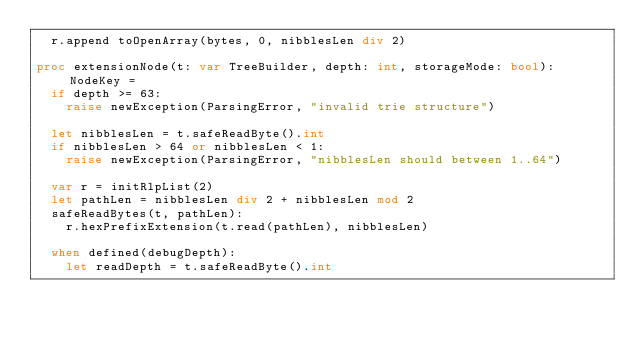<code> <loc_0><loc_0><loc_500><loc_500><_Nim_>  r.append toOpenArray(bytes, 0, nibblesLen div 2)

proc extensionNode(t: var TreeBuilder, depth: int, storageMode: bool): NodeKey =
  if depth >= 63:
    raise newException(ParsingError, "invalid trie structure")

  let nibblesLen = t.safeReadByte().int
  if nibblesLen > 64 or nibblesLen < 1:
    raise newException(ParsingError, "nibblesLen should between 1..64")

  var r = initRlpList(2)
  let pathLen = nibblesLen div 2 + nibblesLen mod 2
  safeReadBytes(t, pathLen):
    r.hexPrefixExtension(t.read(pathLen), nibblesLen)

  when defined(debugDepth):
    let readDepth = t.safeReadByte().int</code> 